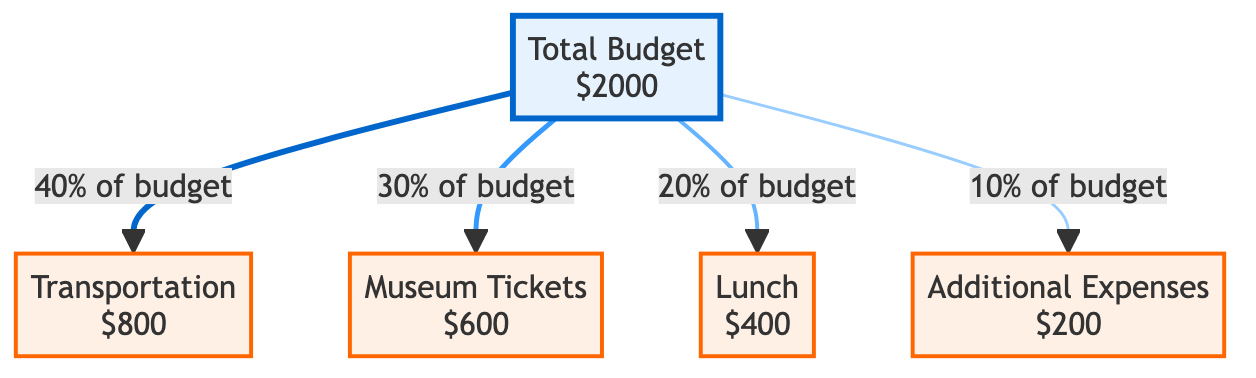What is the total budget allocated for the school tour activities? The total budget is directly stated in the diagram as "$2000".
Answer: $2000 How much is allocated for transportation? The diagram shows a specific node for transportation with an allocation of "$800".
Answer: $800 What percentage of the budget is used for museum tickets? According to the relationship in the diagram, museum tickets account for "30% of budget".
Answer: 30% What are the total expenses listed in the diagram? The diagram lists four expense items: Transportation, Museum Tickets, Lunch, and Additional Expenses. Adding these gives a total of four expenses.
Answer: 4 Which category has the lowest budget allocation? The category labeled "Additional Expenses" has the lowest allocation at "$200".
Answer: Additional Expenses What is the combined percentage allocation of transportation and lunch? The allocation for transportation is "40%" and for lunch is "20%". Adding them gives "40% + 20% = 60%".
Answer: 60% How can the allocation for lunch be described compared to the total budget? Lunch accounts for "20% of the total budget", indicating it's a significant, but not leading, expense.
Answer: 20% What is the relationship between total budget and additional expenses? The diagram indicates that additional expenses are a component of the total budget, specifically "10% of budget".
Answer: 10% How much money is allocated for lunch relative to the cost of museum tickets? Lunch ($400) is less than museum tickets ($600), indicated by the respective values in the diagram.
Answer: $400 is less than $600 